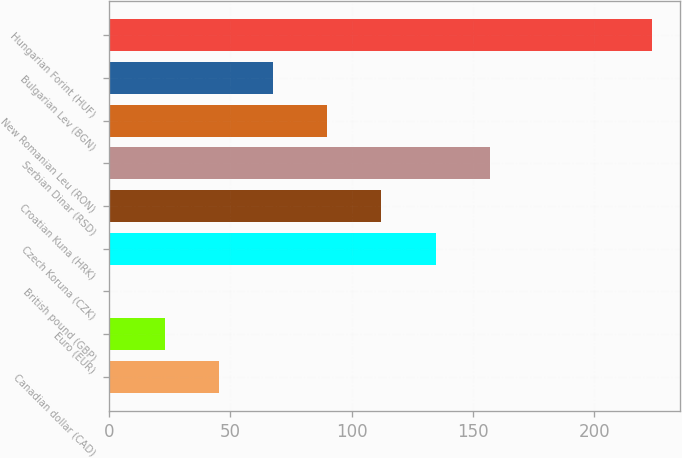Convert chart. <chart><loc_0><loc_0><loc_500><loc_500><bar_chart><fcel>Canadian dollar (CAD)<fcel>Euro (EUR)<fcel>British pound (GBP)<fcel>Czech Koruna (CZK)<fcel>Croatian Kuna (HRK)<fcel>Serbian Dinar (RSD)<fcel>New Romanian Leu (RON)<fcel>Bulgarian Lev (BGN)<fcel>Hungarian Forint (HUF)<nl><fcel>45.3<fcel>22.97<fcel>0.64<fcel>134.62<fcel>112.29<fcel>156.95<fcel>89.96<fcel>67.63<fcel>223.91<nl></chart> 